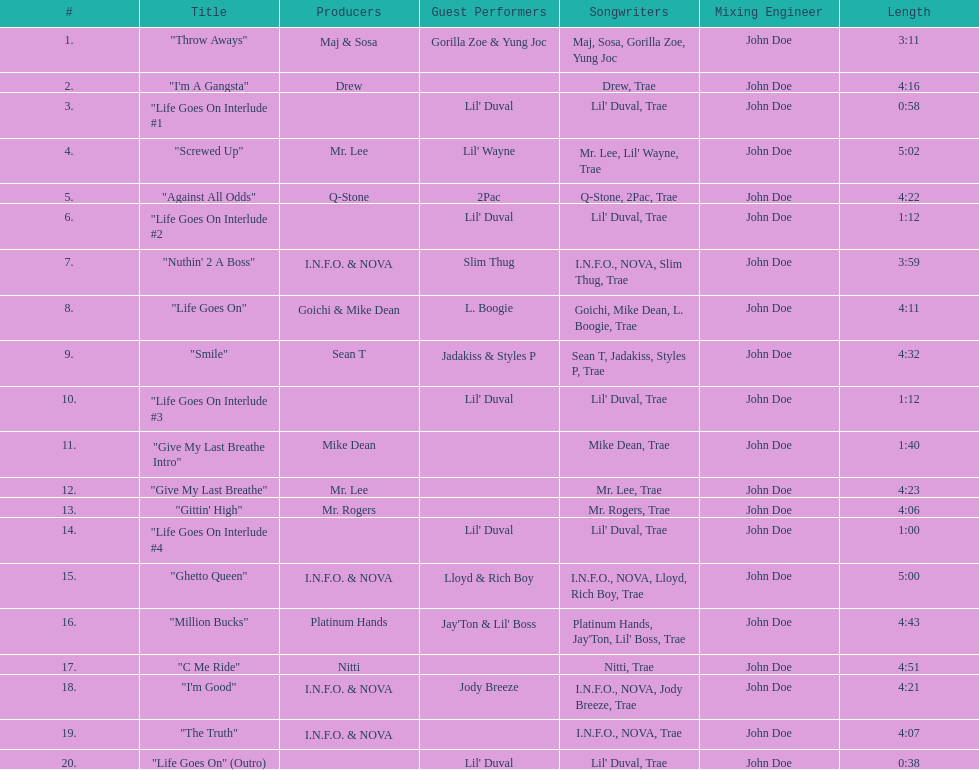How long is the longest track on the album? 5:02. 